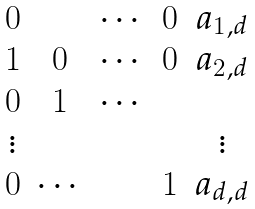Convert formula to latex. <formula><loc_0><loc_0><loc_500><loc_500>\begin{matrix} 0 & & \cdots & 0 & a _ { 1 , d } \\ 1 & 0 & \cdots & 0 & a _ { 2 , d } \\ 0 & 1 & \cdots & \\ \vdots & & & & \vdots \\ 0 & \cdots & & 1 & a _ { d , d } \end{matrix}</formula> 